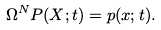<formula> <loc_0><loc_0><loc_500><loc_500>\Omega ^ { N } P ( X ; t ) = p ( x ; t ) .</formula> 